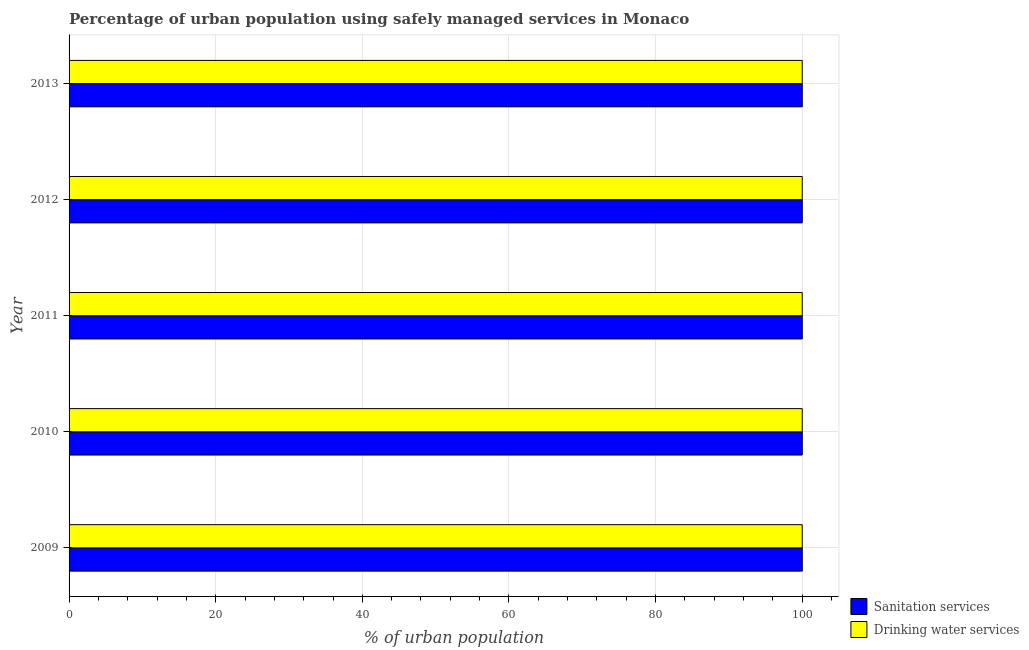How many different coloured bars are there?
Provide a succinct answer. 2. How many groups of bars are there?
Provide a succinct answer. 5. How many bars are there on the 2nd tick from the top?
Keep it short and to the point. 2. How many bars are there on the 3rd tick from the bottom?
Give a very brief answer. 2. In how many cases, is the number of bars for a given year not equal to the number of legend labels?
Provide a succinct answer. 0. What is the percentage of urban population who used drinking water services in 2011?
Your answer should be compact. 100. Across all years, what is the maximum percentage of urban population who used drinking water services?
Your response must be concise. 100. Across all years, what is the minimum percentage of urban population who used drinking water services?
Offer a terse response. 100. In which year was the percentage of urban population who used drinking water services maximum?
Offer a terse response. 2009. In which year was the percentage of urban population who used drinking water services minimum?
Give a very brief answer. 2009. What is the total percentage of urban population who used sanitation services in the graph?
Give a very brief answer. 500. What is the difference between the percentage of urban population who used sanitation services in 2010 and the percentage of urban population who used drinking water services in 2013?
Your answer should be compact. 0. What is the average percentage of urban population who used sanitation services per year?
Give a very brief answer. 100. In how many years, is the percentage of urban population who used sanitation services greater than 32 %?
Offer a terse response. 5. What is the ratio of the percentage of urban population who used drinking water services in 2009 to that in 2013?
Ensure brevity in your answer.  1. Is the percentage of urban population who used drinking water services in 2010 less than that in 2011?
Your response must be concise. No. Is the difference between the percentage of urban population who used drinking water services in 2011 and 2012 greater than the difference between the percentage of urban population who used sanitation services in 2011 and 2012?
Offer a terse response. No. What is the difference between the highest and the second highest percentage of urban population who used sanitation services?
Give a very brief answer. 0. What is the difference between the highest and the lowest percentage of urban population who used sanitation services?
Your answer should be very brief. 0. In how many years, is the percentage of urban population who used sanitation services greater than the average percentage of urban population who used sanitation services taken over all years?
Make the answer very short. 0. What does the 2nd bar from the top in 2010 represents?
Provide a succinct answer. Sanitation services. What does the 1st bar from the bottom in 2013 represents?
Your response must be concise. Sanitation services. How many years are there in the graph?
Provide a succinct answer. 5. What is the difference between two consecutive major ticks on the X-axis?
Make the answer very short. 20. Are the values on the major ticks of X-axis written in scientific E-notation?
Provide a succinct answer. No. Does the graph contain any zero values?
Ensure brevity in your answer.  No. How are the legend labels stacked?
Provide a short and direct response. Vertical. What is the title of the graph?
Provide a succinct answer. Percentage of urban population using safely managed services in Monaco. Does "Birth rate" appear as one of the legend labels in the graph?
Make the answer very short. No. What is the label or title of the X-axis?
Give a very brief answer. % of urban population. What is the label or title of the Y-axis?
Keep it short and to the point. Year. What is the % of urban population of Sanitation services in 2009?
Make the answer very short. 100. What is the % of urban population of Drinking water services in 2009?
Your answer should be compact. 100. What is the % of urban population in Sanitation services in 2010?
Give a very brief answer. 100. What is the % of urban population in Sanitation services in 2011?
Ensure brevity in your answer.  100. What is the % of urban population of Drinking water services in 2011?
Keep it short and to the point. 100. What is the % of urban population of Sanitation services in 2012?
Your answer should be compact. 100. What is the % of urban population in Sanitation services in 2013?
Give a very brief answer. 100. What is the % of urban population of Drinking water services in 2013?
Offer a very short reply. 100. Across all years, what is the minimum % of urban population of Sanitation services?
Provide a succinct answer. 100. Across all years, what is the minimum % of urban population of Drinking water services?
Provide a succinct answer. 100. What is the difference between the % of urban population of Sanitation services in 2009 and that in 2010?
Offer a very short reply. 0. What is the difference between the % of urban population in Sanitation services in 2009 and that in 2012?
Your answer should be compact. 0. What is the difference between the % of urban population of Drinking water services in 2009 and that in 2013?
Make the answer very short. 0. What is the difference between the % of urban population in Sanitation services in 2010 and that in 2012?
Provide a short and direct response. 0. What is the difference between the % of urban population in Drinking water services in 2010 and that in 2012?
Your answer should be very brief. 0. What is the difference between the % of urban population of Sanitation services in 2010 and that in 2013?
Ensure brevity in your answer.  0. What is the difference between the % of urban population of Sanitation services in 2011 and that in 2012?
Keep it short and to the point. 0. What is the difference between the % of urban population in Drinking water services in 2011 and that in 2012?
Your answer should be very brief. 0. What is the difference between the % of urban population of Sanitation services in 2011 and that in 2013?
Offer a very short reply. 0. What is the difference between the % of urban population of Sanitation services in 2012 and that in 2013?
Provide a succinct answer. 0. What is the difference between the % of urban population of Drinking water services in 2012 and that in 2013?
Offer a terse response. 0. What is the difference between the % of urban population of Sanitation services in 2009 and the % of urban population of Drinking water services in 2010?
Your response must be concise. 0. What is the difference between the % of urban population of Sanitation services in 2009 and the % of urban population of Drinking water services in 2011?
Your answer should be compact. 0. What is the difference between the % of urban population in Sanitation services in 2009 and the % of urban population in Drinking water services in 2012?
Provide a succinct answer. 0. What is the difference between the % of urban population of Sanitation services in 2010 and the % of urban population of Drinking water services in 2012?
Your answer should be very brief. 0. What is the difference between the % of urban population of Sanitation services in 2011 and the % of urban population of Drinking water services in 2012?
Provide a short and direct response. 0. What is the difference between the % of urban population of Sanitation services in 2012 and the % of urban population of Drinking water services in 2013?
Ensure brevity in your answer.  0. What is the average % of urban population in Sanitation services per year?
Provide a succinct answer. 100. In the year 2010, what is the difference between the % of urban population in Sanitation services and % of urban population in Drinking water services?
Provide a succinct answer. 0. In the year 2011, what is the difference between the % of urban population in Sanitation services and % of urban population in Drinking water services?
Your response must be concise. 0. What is the ratio of the % of urban population in Sanitation services in 2009 to that in 2010?
Provide a succinct answer. 1. What is the ratio of the % of urban population in Sanitation services in 2009 to that in 2011?
Provide a succinct answer. 1. What is the ratio of the % of urban population in Drinking water services in 2009 to that in 2011?
Make the answer very short. 1. What is the ratio of the % of urban population in Drinking water services in 2009 to that in 2012?
Provide a succinct answer. 1. What is the ratio of the % of urban population of Sanitation services in 2010 to that in 2012?
Keep it short and to the point. 1. What is the ratio of the % of urban population in Sanitation services in 2011 to that in 2012?
Provide a succinct answer. 1. What is the ratio of the % of urban population in Drinking water services in 2011 to that in 2012?
Offer a very short reply. 1. What is the ratio of the % of urban population of Drinking water services in 2011 to that in 2013?
Provide a succinct answer. 1. What is the difference between the highest and the second highest % of urban population of Drinking water services?
Provide a succinct answer. 0. What is the difference between the highest and the lowest % of urban population in Drinking water services?
Provide a succinct answer. 0. 